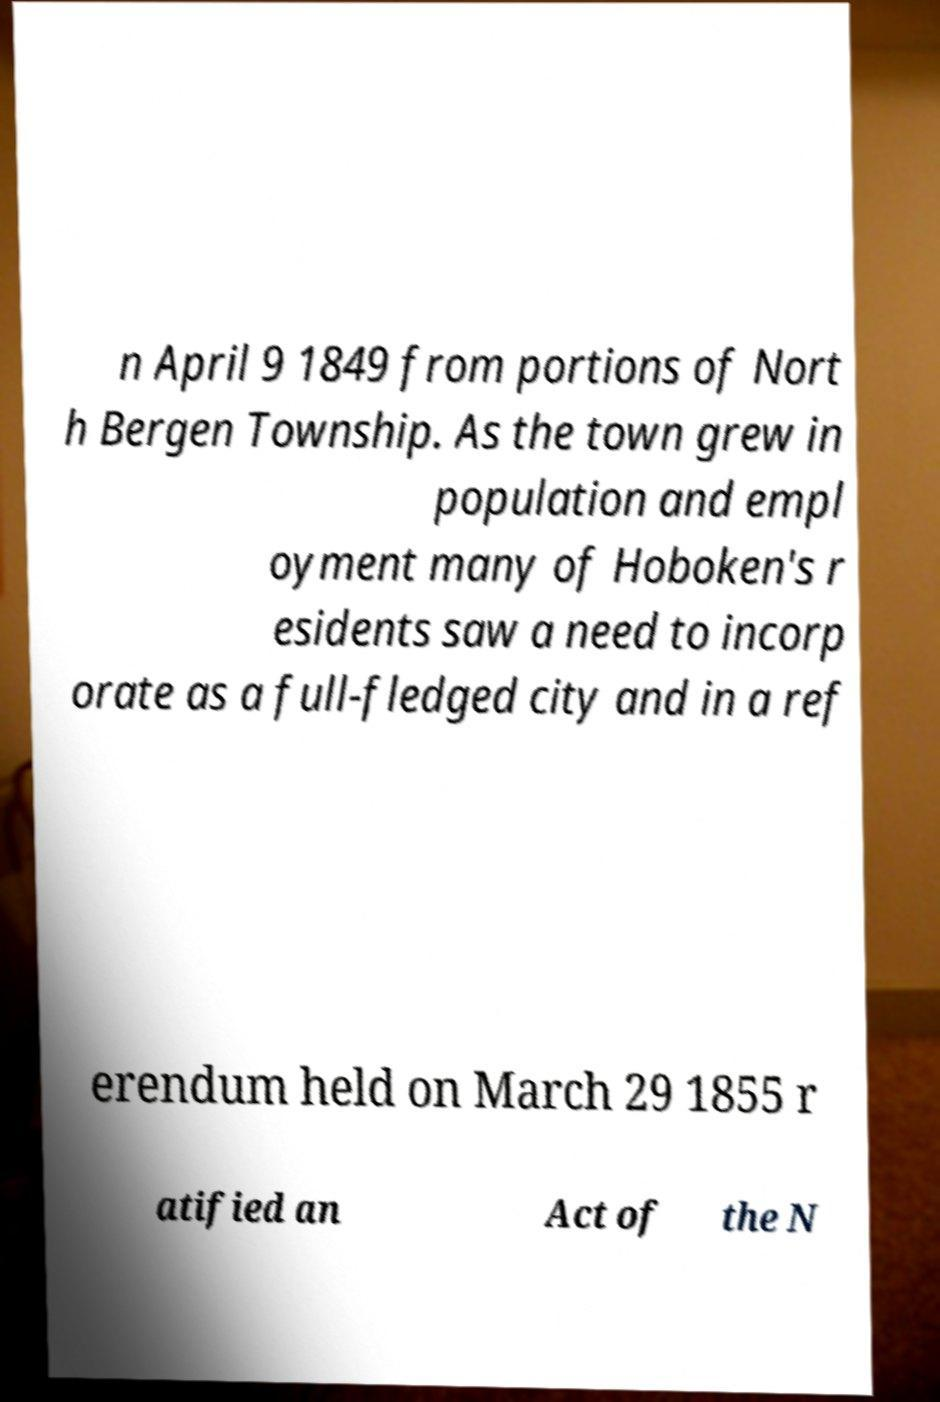Could you extract and type out the text from this image? n April 9 1849 from portions of Nort h Bergen Township. As the town grew in population and empl oyment many of Hoboken's r esidents saw a need to incorp orate as a full-fledged city and in a ref erendum held on March 29 1855 r atified an Act of the N 